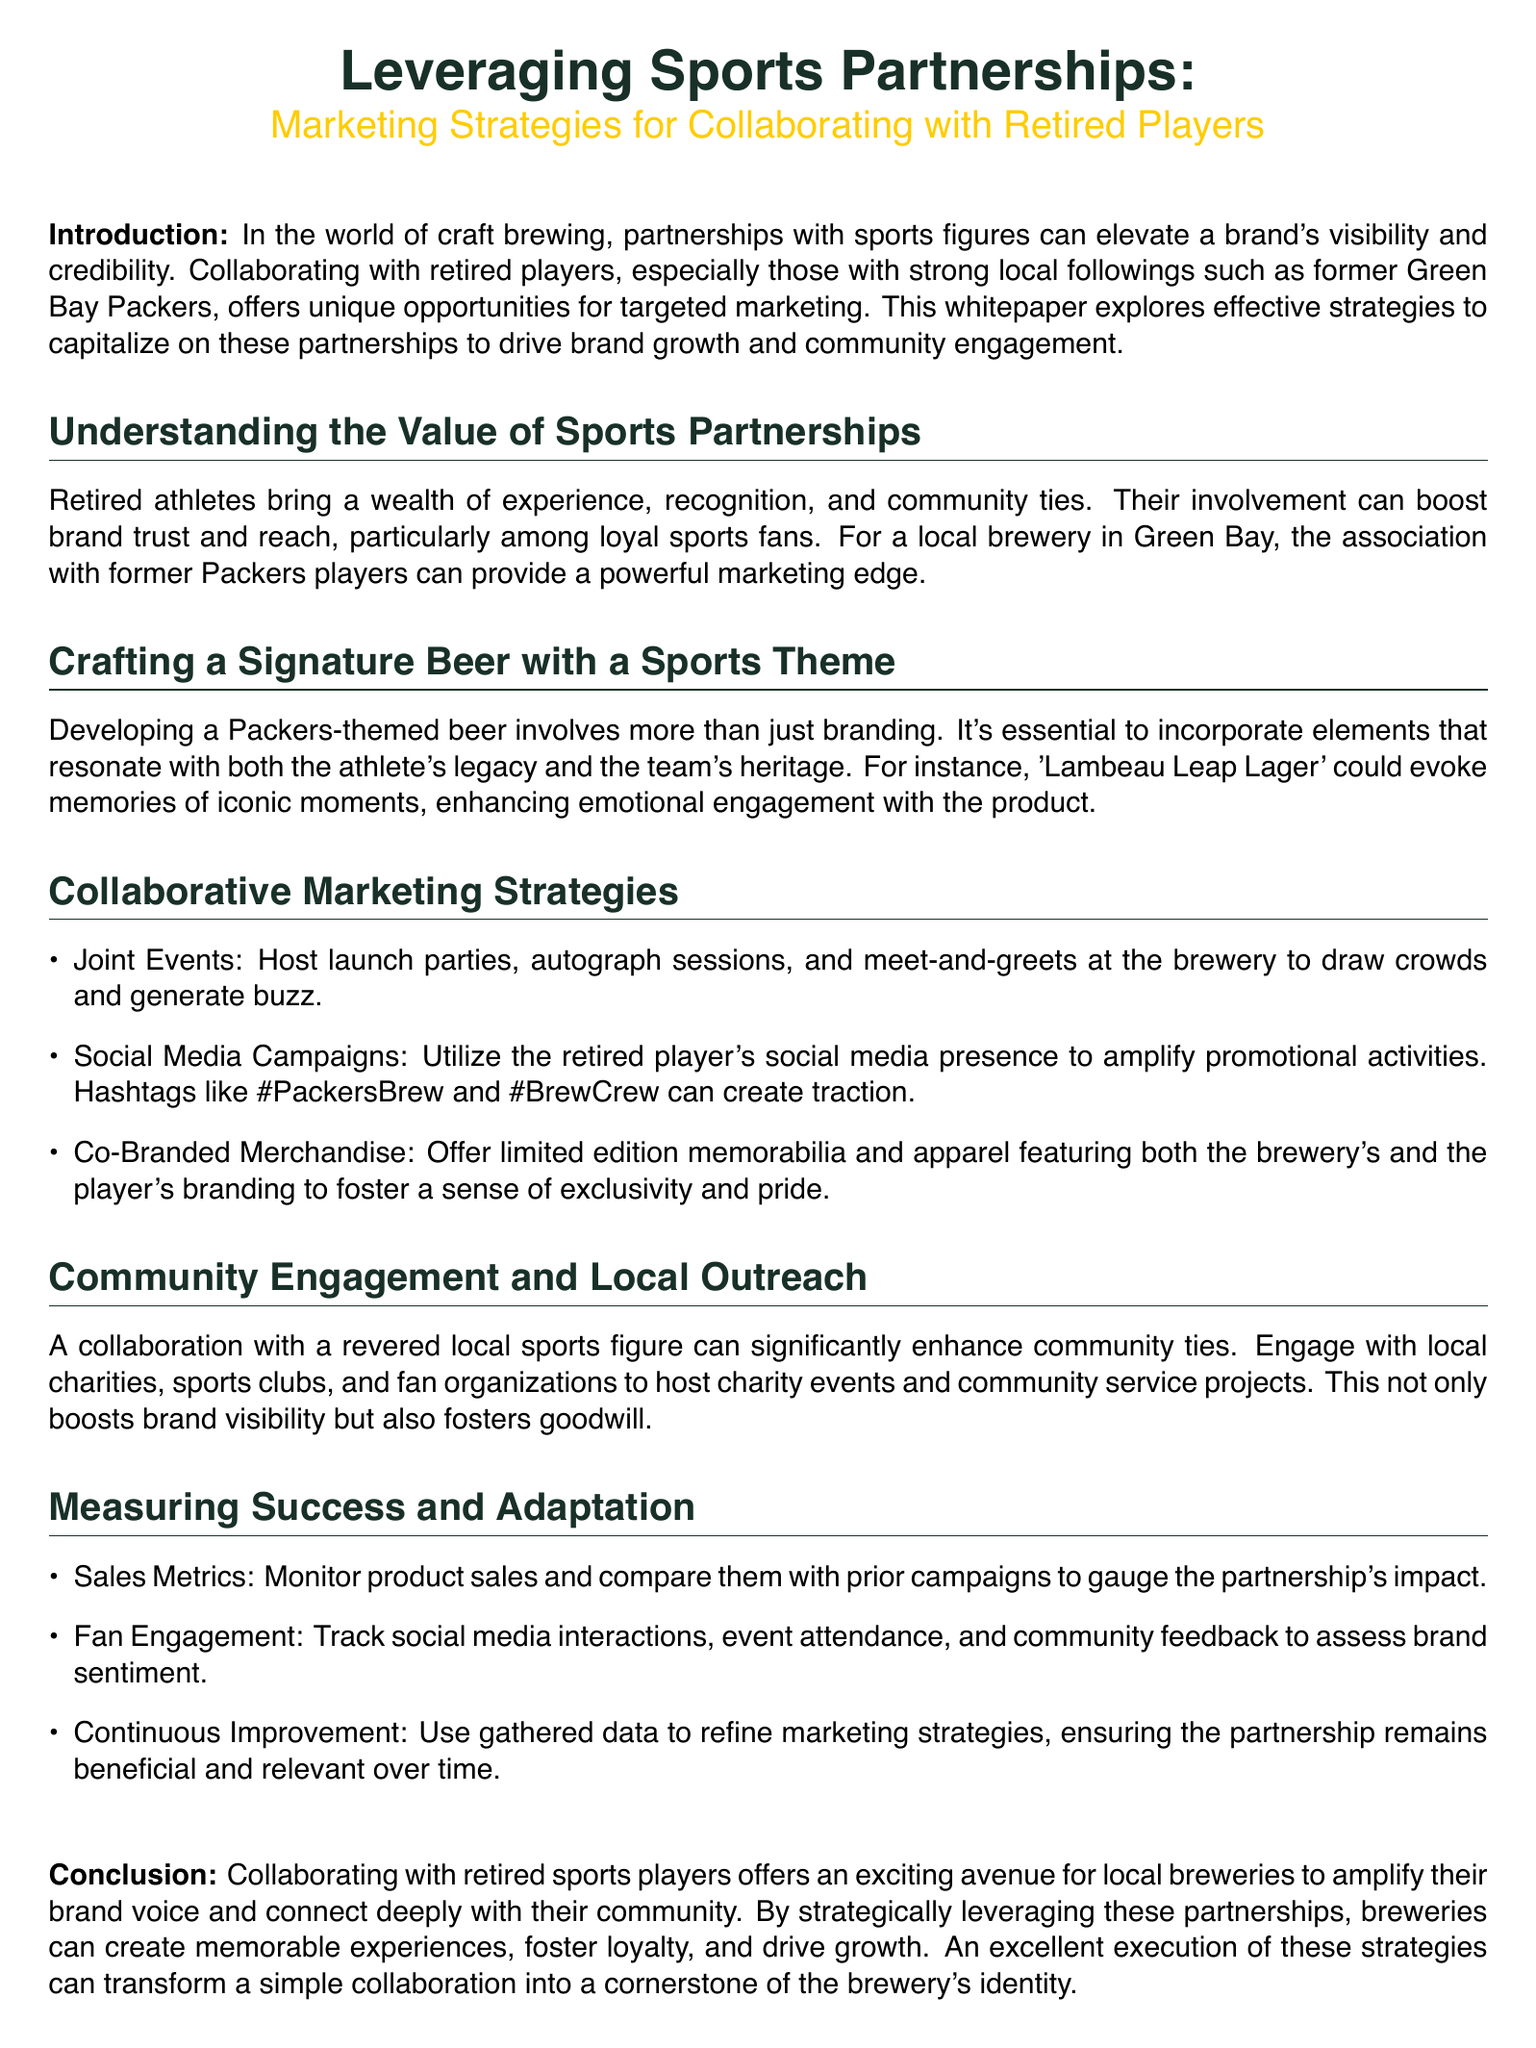What is the title of the whitepaper? The title is prominently displayed at the top of the document, stating the focus on sports partnerships and marketing strategies.
Answer: Leveraging Sports Partnerships: Marketing Strategies for Collaborating with Retired Players What beer name is suggested in the document? The document provides an example name for a Packers-themed beer that resonates with both the athlete's legacy and the team's heritage.
Answer: Lambeau Leap Lager What is one of the joint event ideas mentioned? The document lists collaborative marketing strategies, including specific examples of events that can draw crowds.
Answer: Autograph sessions What are the two suggested hashtags for social media? The document discusses using specific hashtags to enhance promotional activities on social media.
Answer: #PackersBrew and #BrewCrew What type of merchandise is suggested for collaboration? The document recommends offering special items that combine both the brewery's and the player's branding.
Answer: Co-Branded Merchandise What is one metric for measuring partnership success? The document highlights various metrics to assess the impact of the collaboration, focusing on product performance.
Answer: Sales Metrics How can community engagement be enhanced according to the document? The document emphasizes building local ties through specific outreach methods that involve community involvement.
Answer: Charity events What color is used for section titles? The document specifies the color scheme used for different visual elements, particularly in section titles for emphasis.
Answer: Packers green How does the document describe the importance of retired athletes? The whitepaper outlines the benefits that retired players bring to partnerships, which can positively impact branding.
Answer: Community ties 